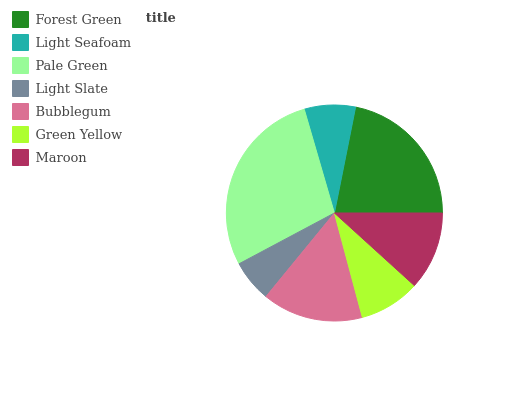Is Light Slate the minimum?
Answer yes or no. Yes. Is Pale Green the maximum?
Answer yes or no. Yes. Is Light Seafoam the minimum?
Answer yes or no. No. Is Light Seafoam the maximum?
Answer yes or no. No. Is Forest Green greater than Light Seafoam?
Answer yes or no. Yes. Is Light Seafoam less than Forest Green?
Answer yes or no. Yes. Is Light Seafoam greater than Forest Green?
Answer yes or no. No. Is Forest Green less than Light Seafoam?
Answer yes or no. No. Is Maroon the high median?
Answer yes or no. Yes. Is Maroon the low median?
Answer yes or no. Yes. Is Pale Green the high median?
Answer yes or no. No. Is Pale Green the low median?
Answer yes or no. No. 